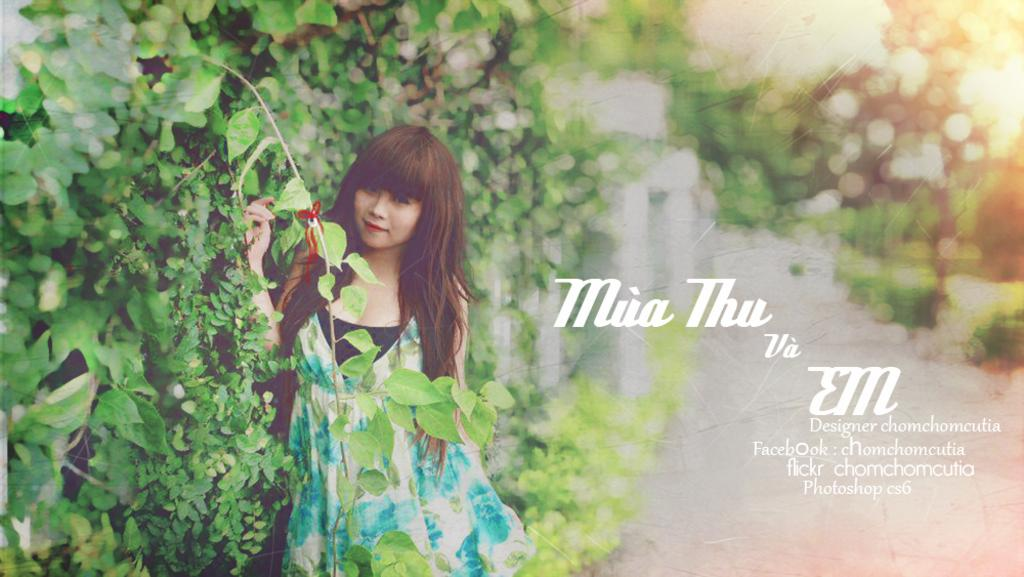Who is the main subject in the image? There is a girl in the image. What is the girl doing in the image? The girl is standing at a wall. What can be seen in the background of the image? There are trees in the image. What type of planes can be seen flying in the image? There are no planes visible in the image; it features a girl standing at a wall with trees in the background. 